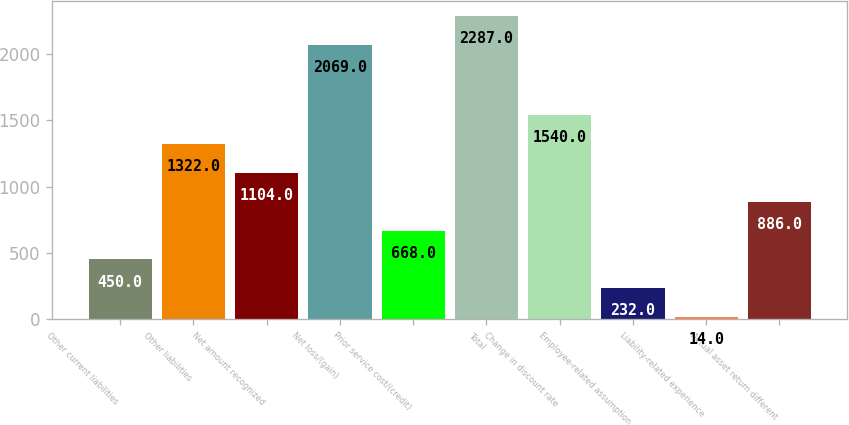<chart> <loc_0><loc_0><loc_500><loc_500><bar_chart><fcel>Other current liabilities<fcel>Other liabilities<fcel>Net amount recognized<fcel>Net loss/(gain)<fcel>Prior service cost/(credit)<fcel>Total<fcel>Change in discount rate<fcel>Employee-related assumption<fcel>Liability-related experience<fcel>Actual asset return different<nl><fcel>450<fcel>1322<fcel>1104<fcel>2069<fcel>668<fcel>2287<fcel>1540<fcel>232<fcel>14<fcel>886<nl></chart> 